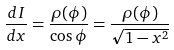Convert formula to latex. <formula><loc_0><loc_0><loc_500><loc_500>\frac { d I } { d x } = \frac { \rho ( \phi ) } { \cos \phi } = \frac { \rho ( \phi ) } { \sqrt { 1 - x ^ { 2 } } }</formula> 